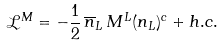<formula> <loc_0><loc_0><loc_500><loc_500>\mathcal { L } ^ { M } = - \frac { 1 } { 2 } \, \overline { n } _ { L } \, M ^ { L } ( n _ { L } ) ^ { c } + h . c .</formula> 